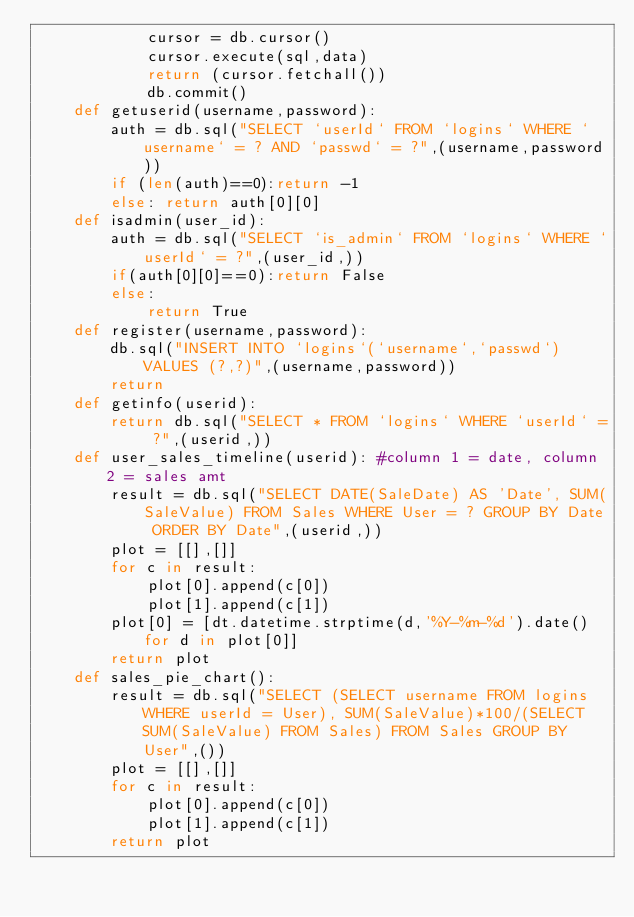<code> <loc_0><loc_0><loc_500><loc_500><_Python_>            cursor = db.cursor()
            cursor.execute(sql,data)
            return (cursor.fetchall())
            db.commit()
    def getuserid(username,password):
        auth = db.sql("SELECT `userId` FROM `logins` WHERE `username` = ? AND `passwd` = ?",(username,password))
        if (len(auth)==0):return -1
        else: return auth[0][0]
    def isadmin(user_id):
        auth = db.sql("SELECT `is_admin` FROM `logins` WHERE `userId` = ?",(user_id,))
        if(auth[0][0]==0):return False
        else:
            return True
    def register(username,password):
        db.sql("INSERT INTO `logins`(`username`,`passwd`) VALUES (?,?)",(username,password))
        return
    def getinfo(userid):
        return db.sql("SELECT * FROM `logins` WHERE `userId` = ?",(userid,))
    def user_sales_timeline(userid): #column 1 = date, column 2 = sales amt
        result = db.sql("SELECT DATE(SaleDate) AS 'Date', SUM(SaleValue) FROM Sales WHERE User = ? GROUP BY Date ORDER BY Date",(userid,))
        plot = [[],[]]
        for c in result:
            plot[0].append(c[0])
            plot[1].append(c[1])
        plot[0] = [dt.datetime.strptime(d,'%Y-%m-%d').date() for d in plot[0]]
        return plot
    def sales_pie_chart():
        result = db.sql("SELECT (SELECT username FROM logins WHERE userId = User), SUM(SaleValue)*100/(SELECT SUM(SaleValue) FROM Sales) FROM Sales GROUP BY User",())
        plot = [[],[]]
        for c in result:
            plot[0].append(c[0])
            plot[1].append(c[1])
        return plot

</code> 